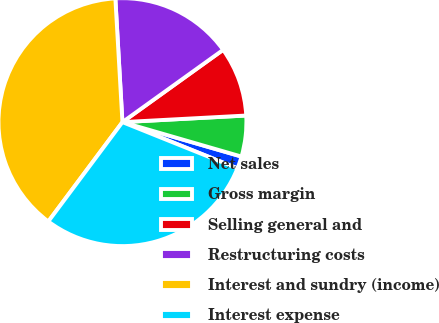Convert chart. <chart><loc_0><loc_0><loc_500><loc_500><pie_chart><fcel>Net sales<fcel>Gross margin<fcel>Selling general and<fcel>Restructuring costs<fcel>Interest and sundry (income)<fcel>Interest expense<nl><fcel>1.6%<fcel>5.33%<fcel>9.06%<fcel>16.0%<fcel>38.89%<fcel>29.12%<nl></chart> 